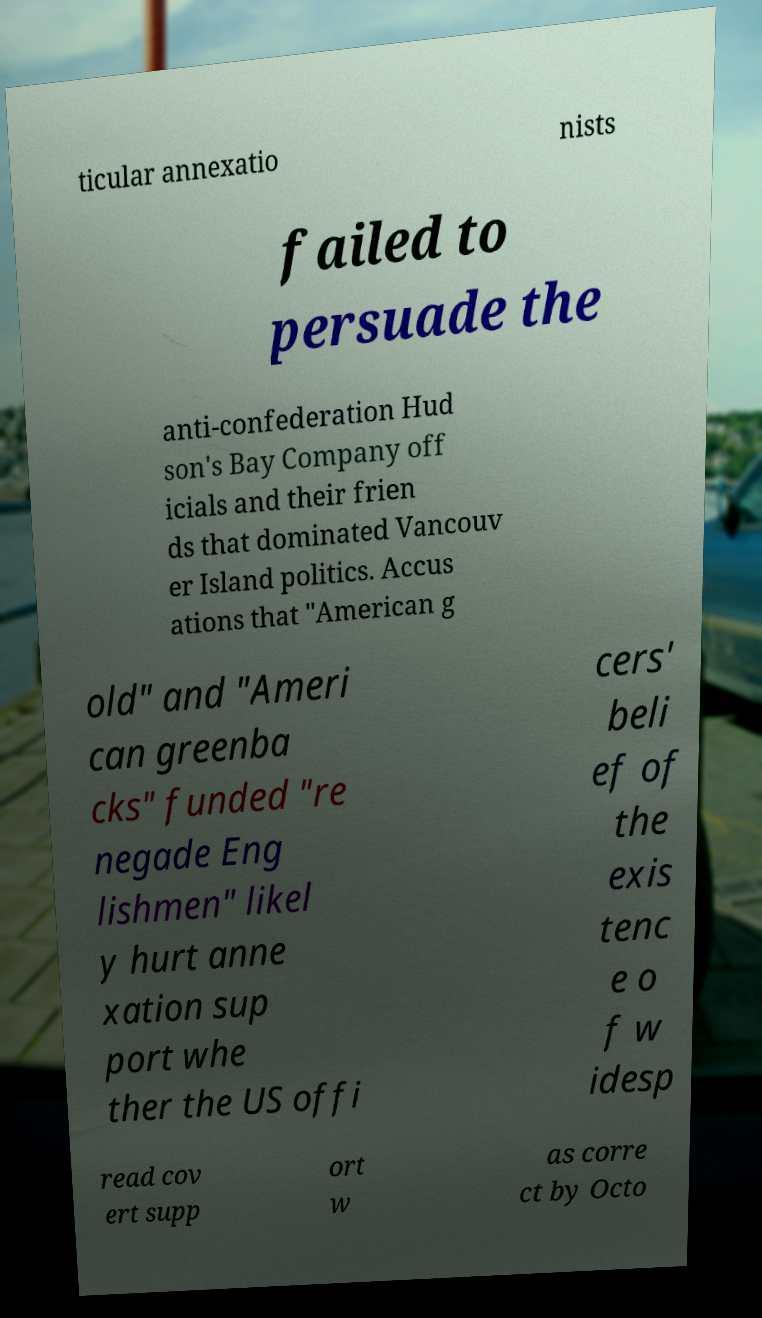Could you extract and type out the text from this image? ticular annexatio nists failed to persuade the anti-confederation Hud son's Bay Company off icials and their frien ds that dominated Vancouv er Island politics. Accus ations that "American g old" and "Ameri can greenba cks" funded "re negade Eng lishmen" likel y hurt anne xation sup port whe ther the US offi cers' beli ef of the exis tenc e o f w idesp read cov ert supp ort w as corre ct by Octo 